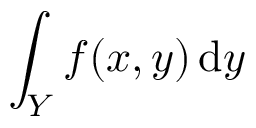<formula> <loc_0><loc_0><loc_500><loc_500>\int _ { Y } f ( x , y ) \, { d } y</formula> 